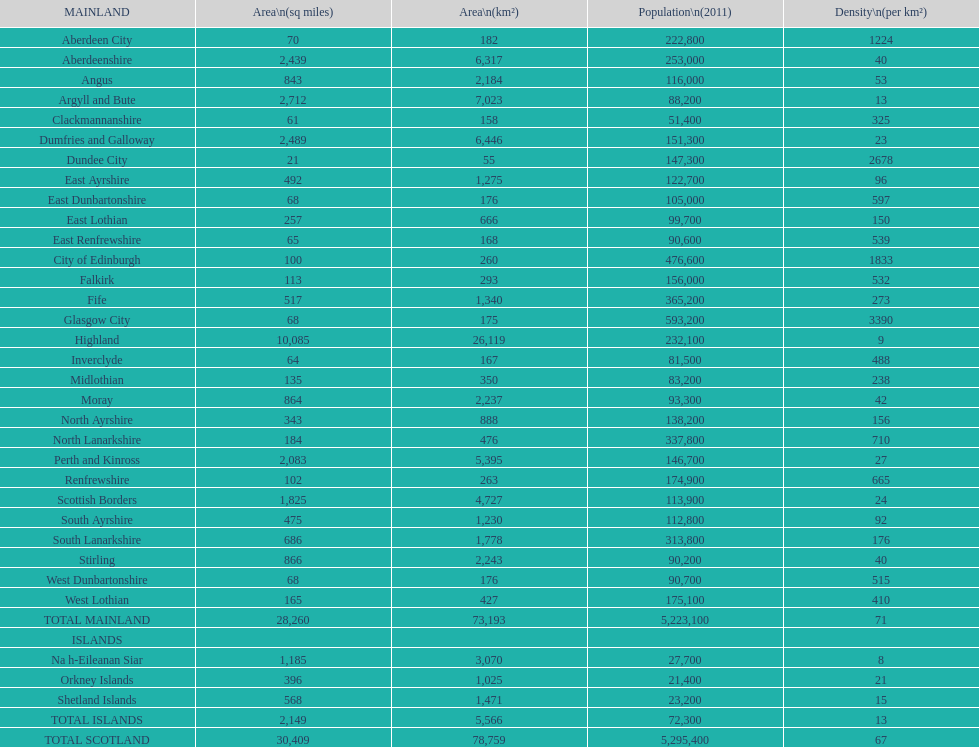Which mainland area has the fewest inhabitants? Clackmannanshire. 